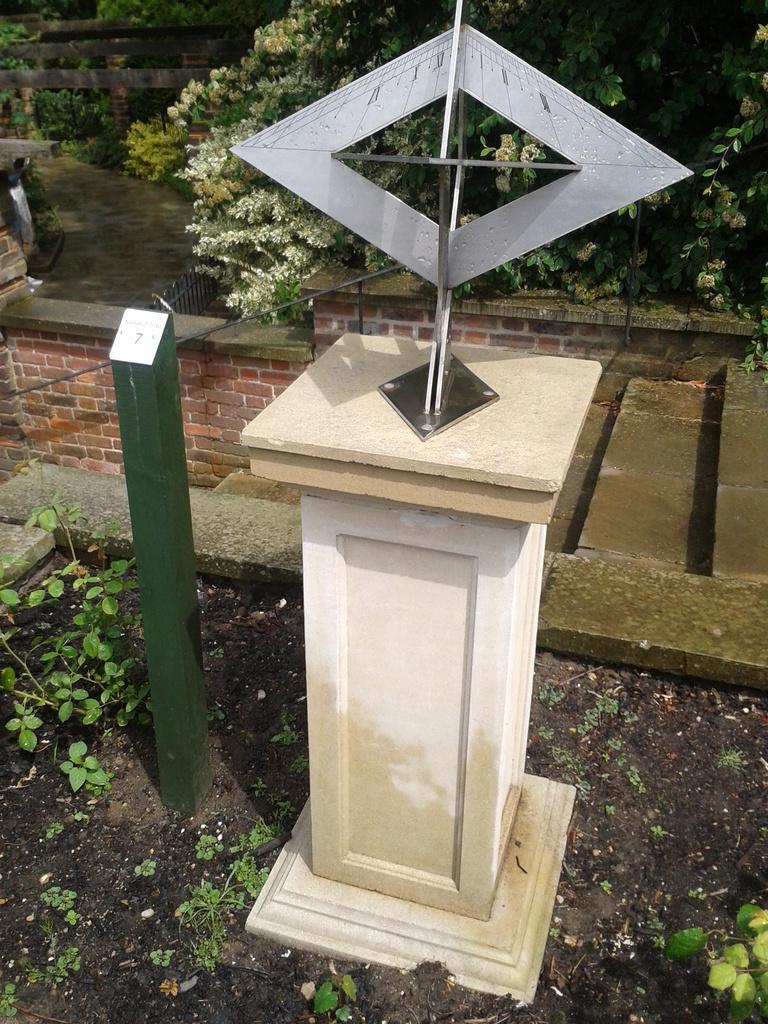Could you give a brief overview of what you see in this image? In the center of the image we can see one object placed on the solid structure. On the left side of the image, we can see one pole, which is in green and white color. In the background there is a fence, wall, staircase, plants, trees and a few other objects. 